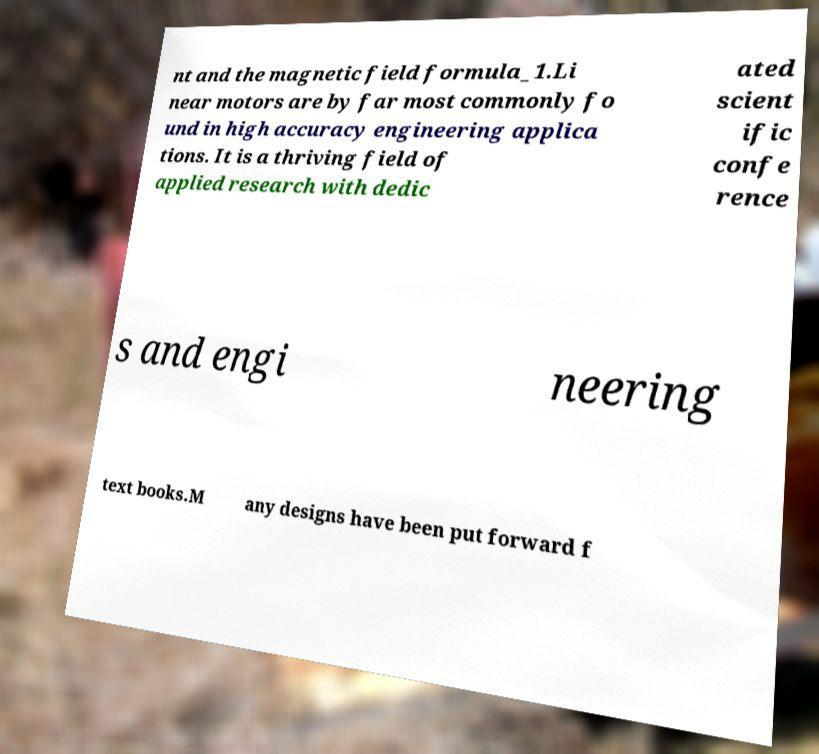There's text embedded in this image that I need extracted. Can you transcribe it verbatim? nt and the magnetic field formula_1.Li near motors are by far most commonly fo und in high accuracy engineering applica tions. It is a thriving field of applied research with dedic ated scient ific confe rence s and engi neering text books.M any designs have been put forward f 